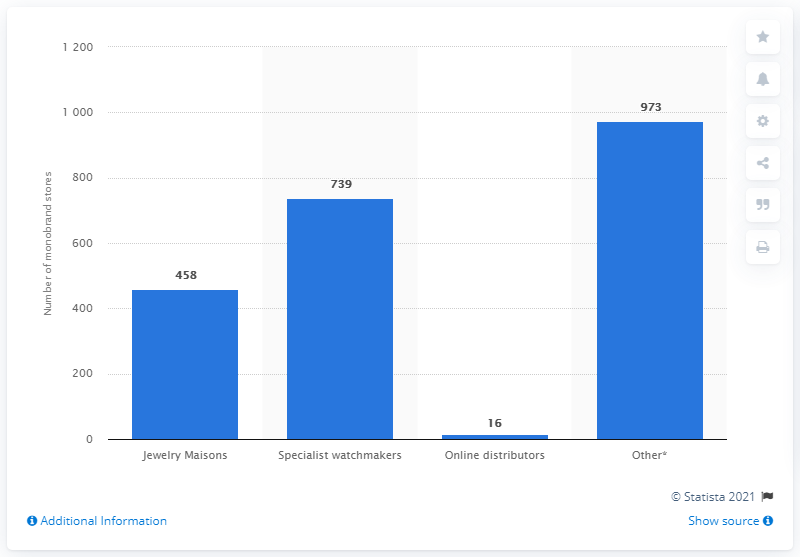Specify some key components in this picture. As of September 30, 2020, the jewelry maison division of Richemont Group operated 458 monobrand stores. 